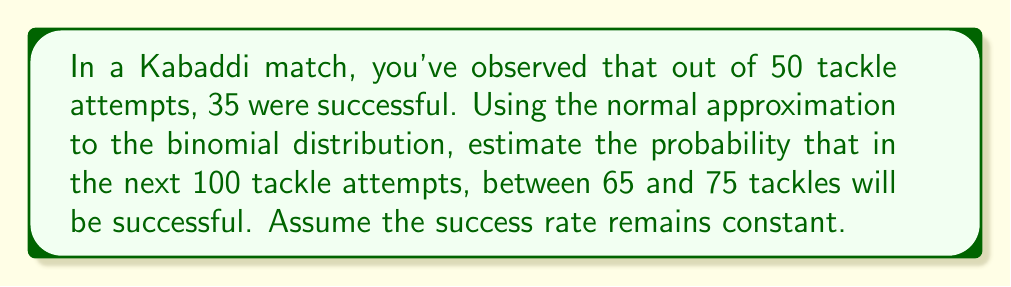Provide a solution to this math problem. Let's approach this step-by-step:

1) First, we need to calculate the sample proportion of successful tackles:
   $p = \frac{35}{50} = 0.7$

2) For the normal approximation to be valid, we need to check if $np \geq 5$ and $n(1-p) \geq 5$:
   $100 * 0.7 = 70 \geq 5$ and $100 * (1-0.7) = 30 \geq 5$
   So, the conditions are met.

3) The mean of the distribution will be:
   $\mu = np = 100 * 0.7 = 70$

4) The standard deviation will be:
   $\sigma = \sqrt{np(1-p)} = \sqrt{100 * 0.7 * 0.3} = \sqrt{21} \approx 4.58$

5) We need to find $P(65 \leq X \leq 75)$, where X is the number of successful tackles.

6) Standardizing the random variable:
   $P(65 \leq X \leq 75) = P(\frac{65 - 70}{4.58} \leq Z \leq \frac{75 - 70}{4.58})$
   $= P(-1.09 \leq Z \leq 1.09)$

7) Using the standard normal distribution table or calculator:
   $P(-1.09 \leq Z \leq 1.09) = P(Z \leq 1.09) - P(Z \leq -1.09)$
   $= 0.8621 - 0.1379 = 0.7242$

Therefore, the probability of having between 65 and 75 successful tackles in the next 100 attempts is approximately 0.7242 or 72.42%.
Answer: 0.7242 